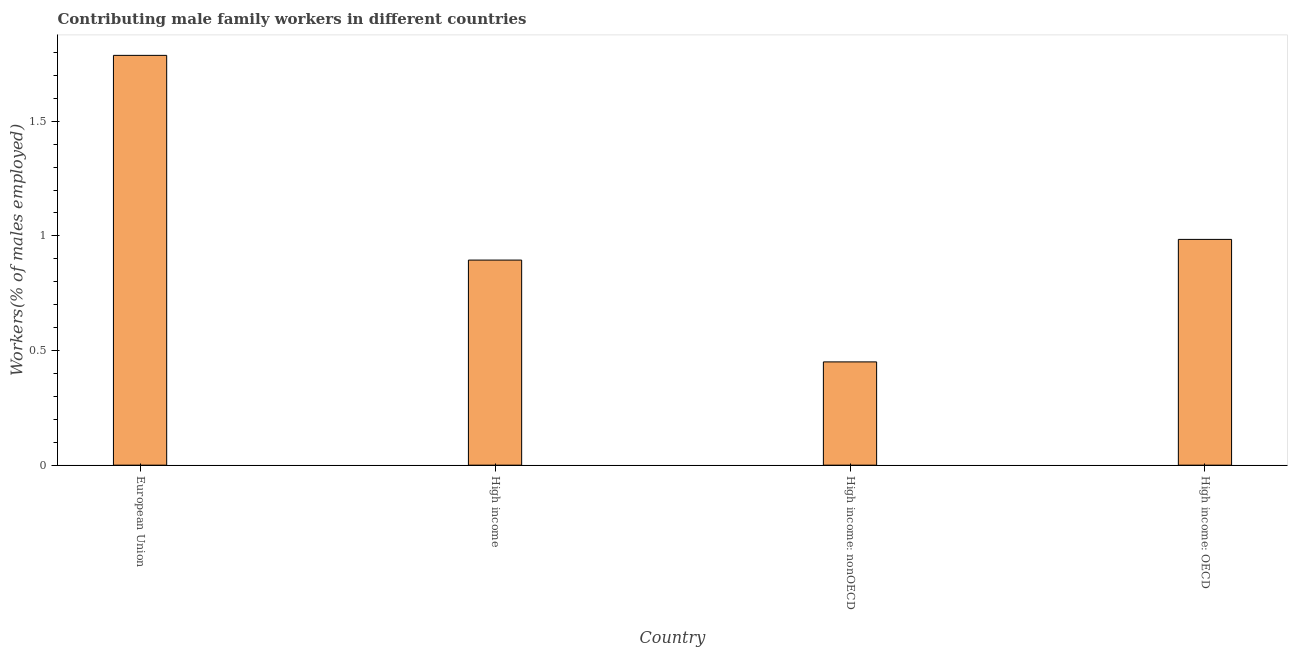Does the graph contain grids?
Offer a very short reply. No. What is the title of the graph?
Offer a terse response. Contributing male family workers in different countries. What is the label or title of the X-axis?
Ensure brevity in your answer.  Country. What is the label or title of the Y-axis?
Offer a terse response. Workers(% of males employed). What is the contributing male family workers in High income: OECD?
Provide a succinct answer. 0.98. Across all countries, what is the maximum contributing male family workers?
Provide a succinct answer. 1.79. Across all countries, what is the minimum contributing male family workers?
Keep it short and to the point. 0.45. In which country was the contributing male family workers minimum?
Make the answer very short. High income: nonOECD. What is the sum of the contributing male family workers?
Offer a terse response. 4.12. What is the difference between the contributing male family workers in High income: OECD and High income: nonOECD?
Keep it short and to the point. 0.53. What is the median contributing male family workers?
Offer a very short reply. 0.94. What is the ratio of the contributing male family workers in European Union to that in High income: OECD?
Your response must be concise. 1.81. Is the contributing male family workers in High income less than that in High income: OECD?
Provide a succinct answer. Yes. What is the difference between the highest and the second highest contributing male family workers?
Keep it short and to the point. 0.8. Is the sum of the contributing male family workers in European Union and High income greater than the maximum contributing male family workers across all countries?
Ensure brevity in your answer.  Yes. What is the difference between the highest and the lowest contributing male family workers?
Your answer should be compact. 1.34. In how many countries, is the contributing male family workers greater than the average contributing male family workers taken over all countries?
Your answer should be very brief. 1. How many countries are there in the graph?
Offer a terse response. 4. What is the difference between two consecutive major ticks on the Y-axis?
Ensure brevity in your answer.  0.5. What is the Workers(% of males employed) of European Union?
Your answer should be compact. 1.79. What is the Workers(% of males employed) in High income?
Offer a very short reply. 0.89. What is the Workers(% of males employed) of High income: nonOECD?
Offer a terse response. 0.45. What is the Workers(% of males employed) of High income: OECD?
Your answer should be very brief. 0.98. What is the difference between the Workers(% of males employed) in European Union and High income?
Offer a very short reply. 0.89. What is the difference between the Workers(% of males employed) in European Union and High income: nonOECD?
Your answer should be compact. 1.34. What is the difference between the Workers(% of males employed) in European Union and High income: OECD?
Your answer should be very brief. 0.8. What is the difference between the Workers(% of males employed) in High income and High income: nonOECD?
Your answer should be compact. 0.44. What is the difference between the Workers(% of males employed) in High income and High income: OECD?
Make the answer very short. -0.09. What is the difference between the Workers(% of males employed) in High income: nonOECD and High income: OECD?
Your response must be concise. -0.53. What is the ratio of the Workers(% of males employed) in European Union to that in High income?
Make the answer very short. 2. What is the ratio of the Workers(% of males employed) in European Union to that in High income: nonOECD?
Your response must be concise. 3.97. What is the ratio of the Workers(% of males employed) in European Union to that in High income: OECD?
Ensure brevity in your answer.  1.81. What is the ratio of the Workers(% of males employed) in High income to that in High income: nonOECD?
Offer a terse response. 1.99. What is the ratio of the Workers(% of males employed) in High income to that in High income: OECD?
Your answer should be compact. 0.91. What is the ratio of the Workers(% of males employed) in High income: nonOECD to that in High income: OECD?
Make the answer very short. 0.46. 